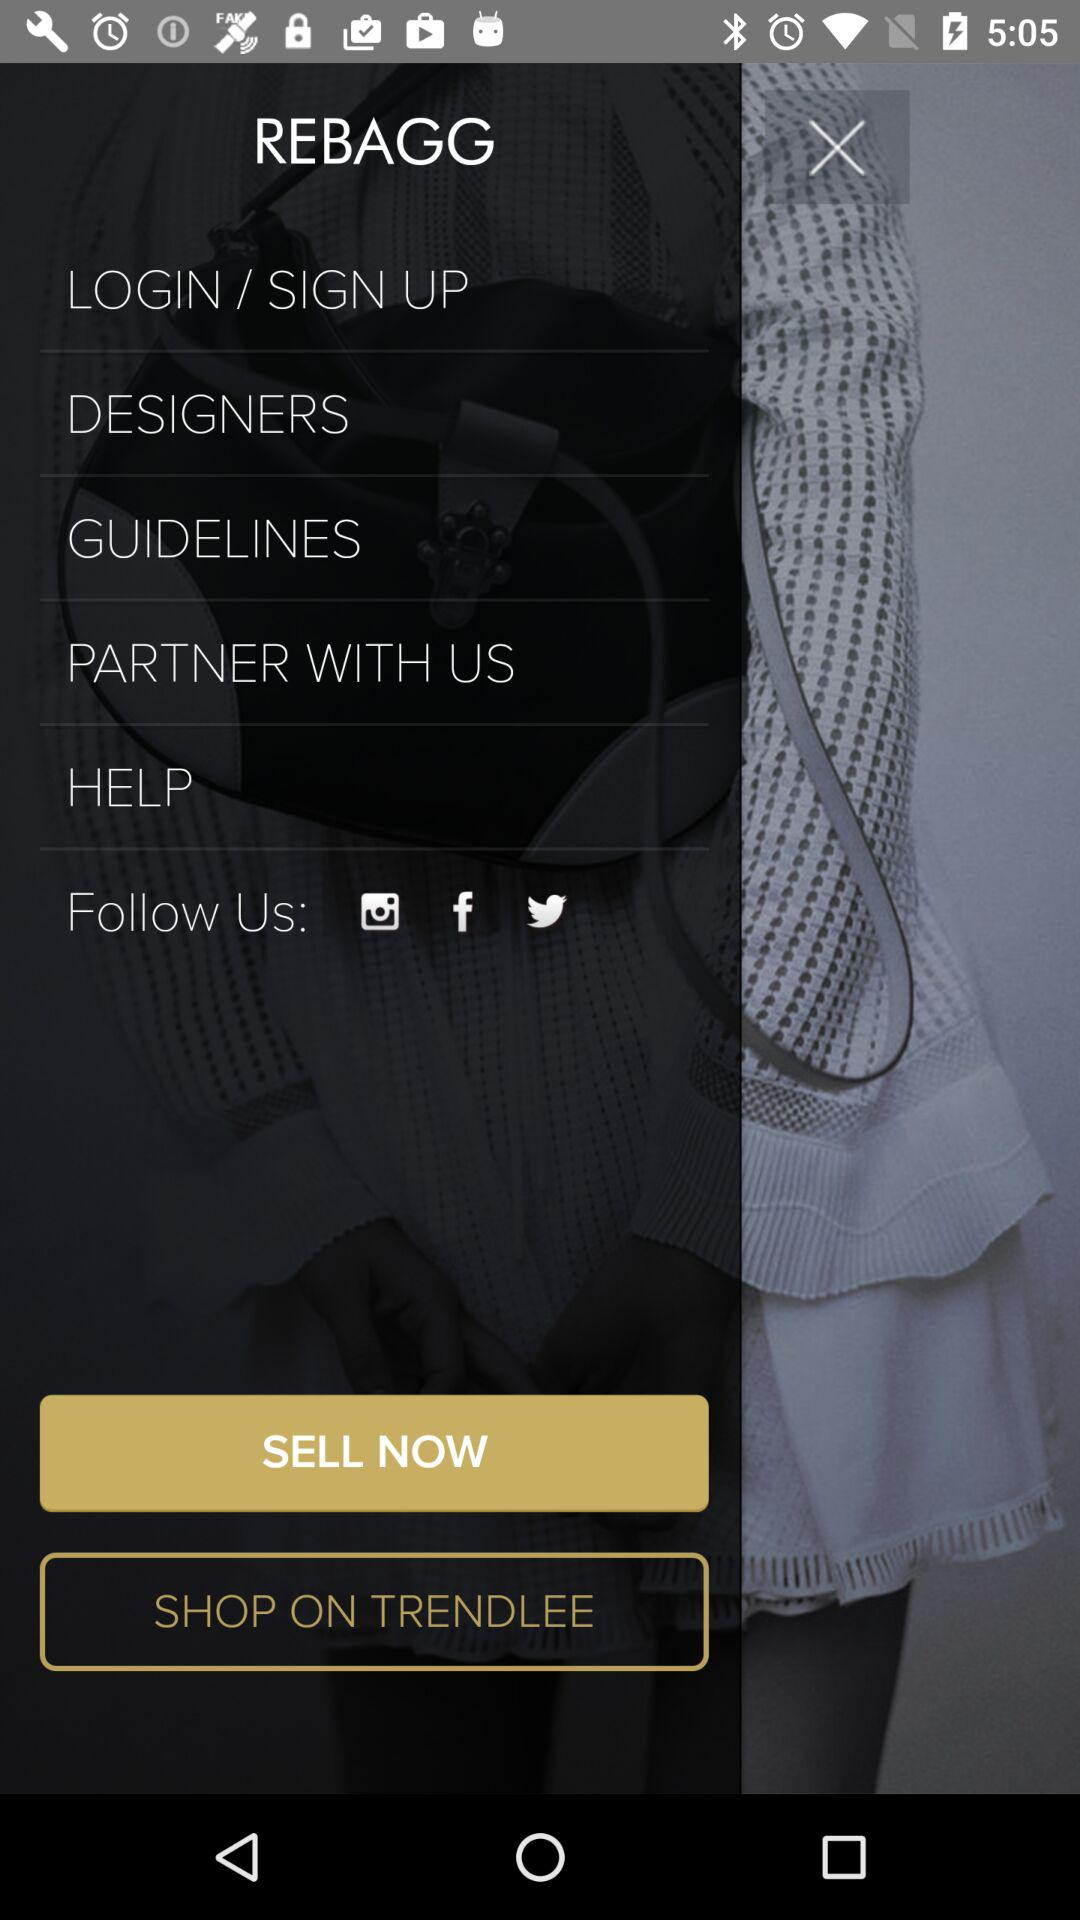What is the application name? The application name is "REBAGG". 